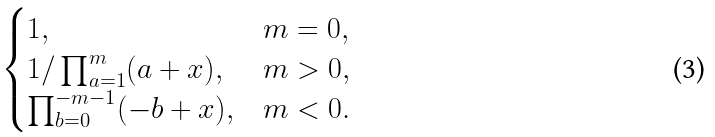<formula> <loc_0><loc_0><loc_500><loc_500>\begin{cases} 1 , & m = 0 , \\ 1 / \prod _ { a = 1 } ^ { m } ( a + x ) , & m > 0 , \\ \prod _ { b = 0 } ^ { - m - 1 } ( - b + x ) , & m < 0 . \end{cases}</formula> 